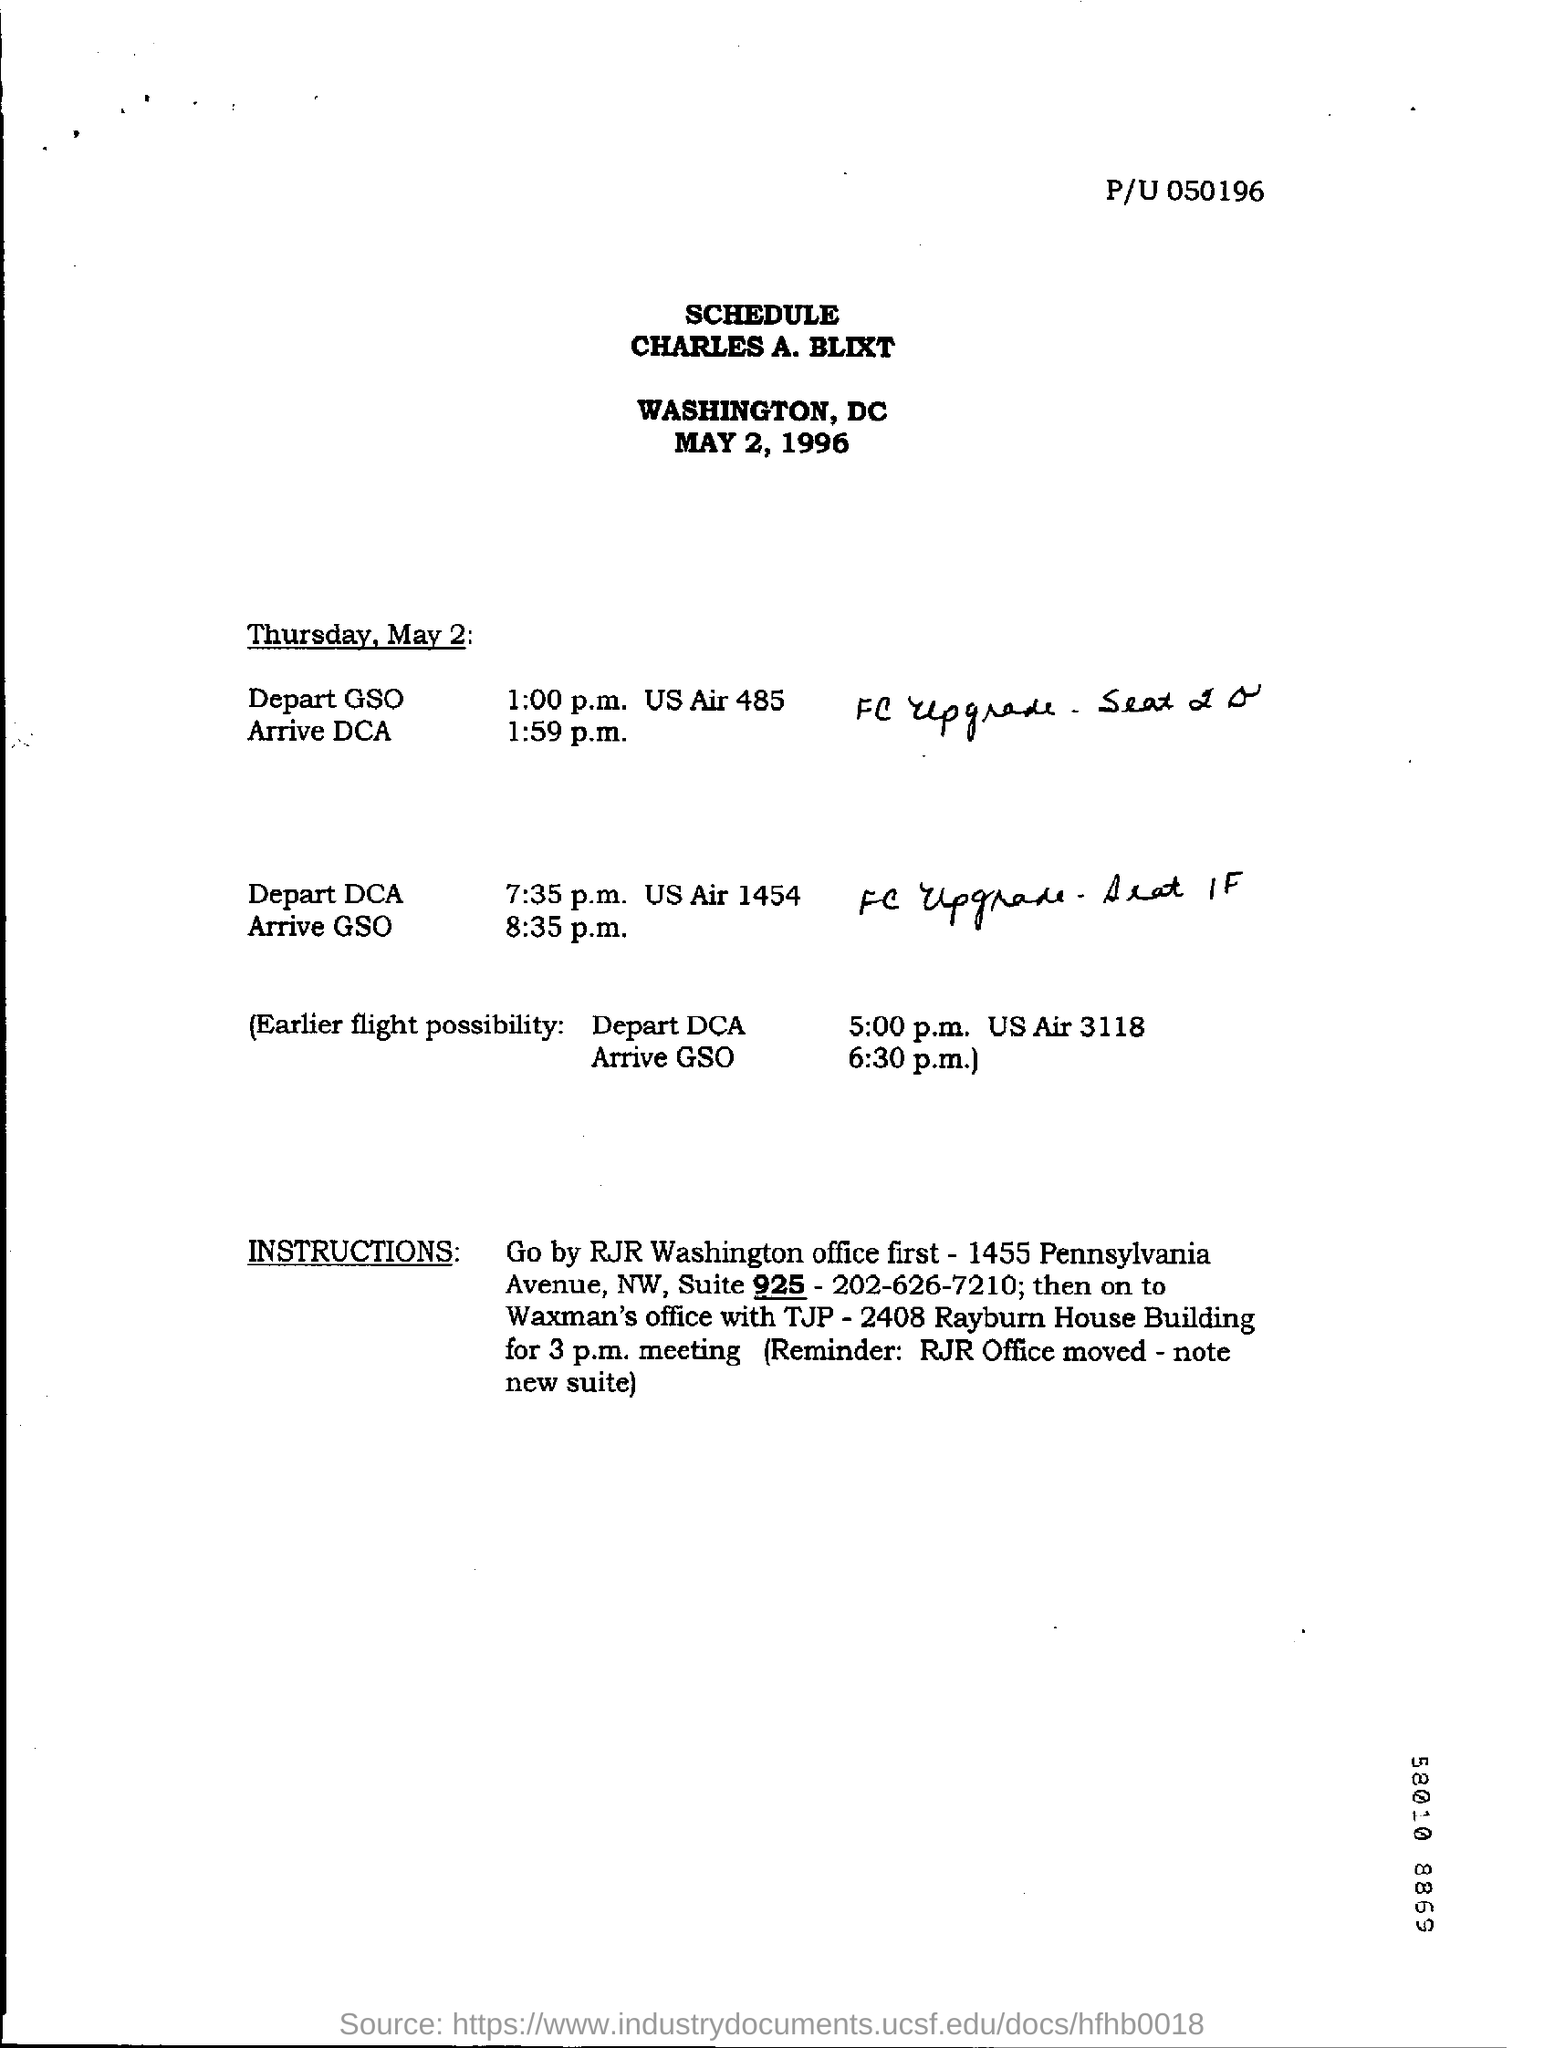List a handful of essential elements in this visual. On May 2nd, Thursday will occur. On what date was the schedule prepared for? May 2, 1996. 